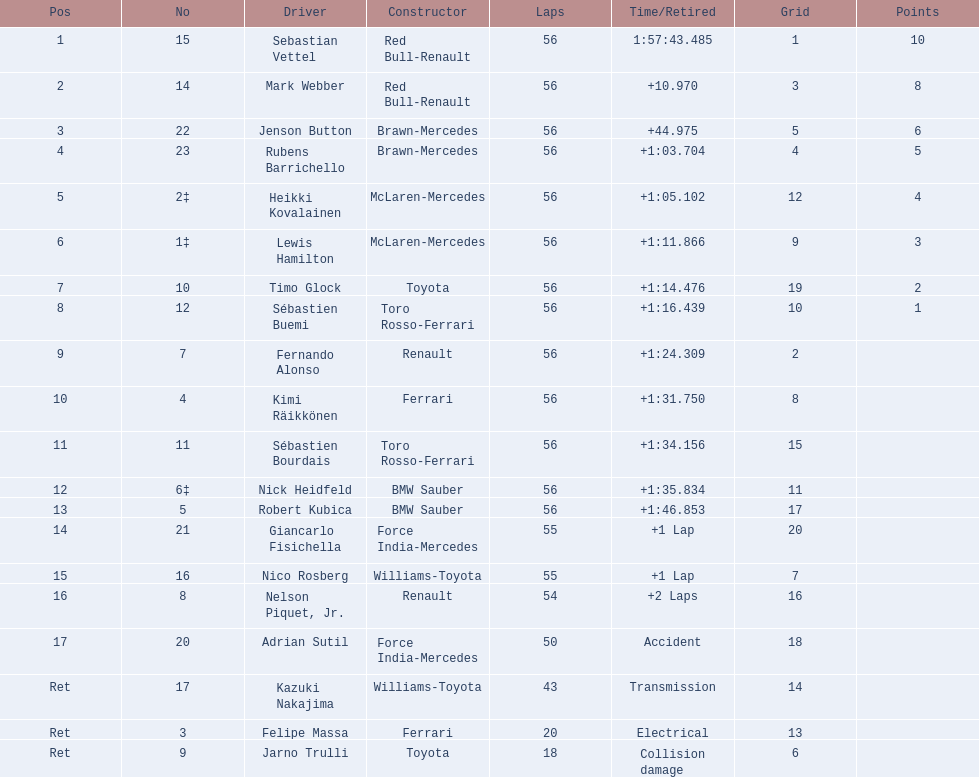Which drivers raced in the 2009 chinese grand prix? Sebastian Vettel, Mark Webber, Jenson Button, Rubens Barrichello, Heikki Kovalainen, Lewis Hamilton, Timo Glock, Sébastien Buemi, Fernando Alonso, Kimi Räikkönen, Sébastien Bourdais, Nick Heidfeld, Robert Kubica, Giancarlo Fisichella, Nico Rosberg, Nelson Piquet, Jr., Adrian Sutil, Kazuki Nakajima, Felipe Massa, Jarno Trulli. Of the drivers in the 2009 chinese grand prix, which finished the race? Sebastian Vettel, Mark Webber, Jenson Button, Rubens Barrichello, Heikki Kovalainen, Lewis Hamilton, Timo Glock, Sébastien Buemi, Fernando Alonso, Kimi Räikkönen, Sébastien Bourdais, Nick Heidfeld, Robert Kubica. Of the drivers who finished the race, who had the slowest time? Robert Kubica. 